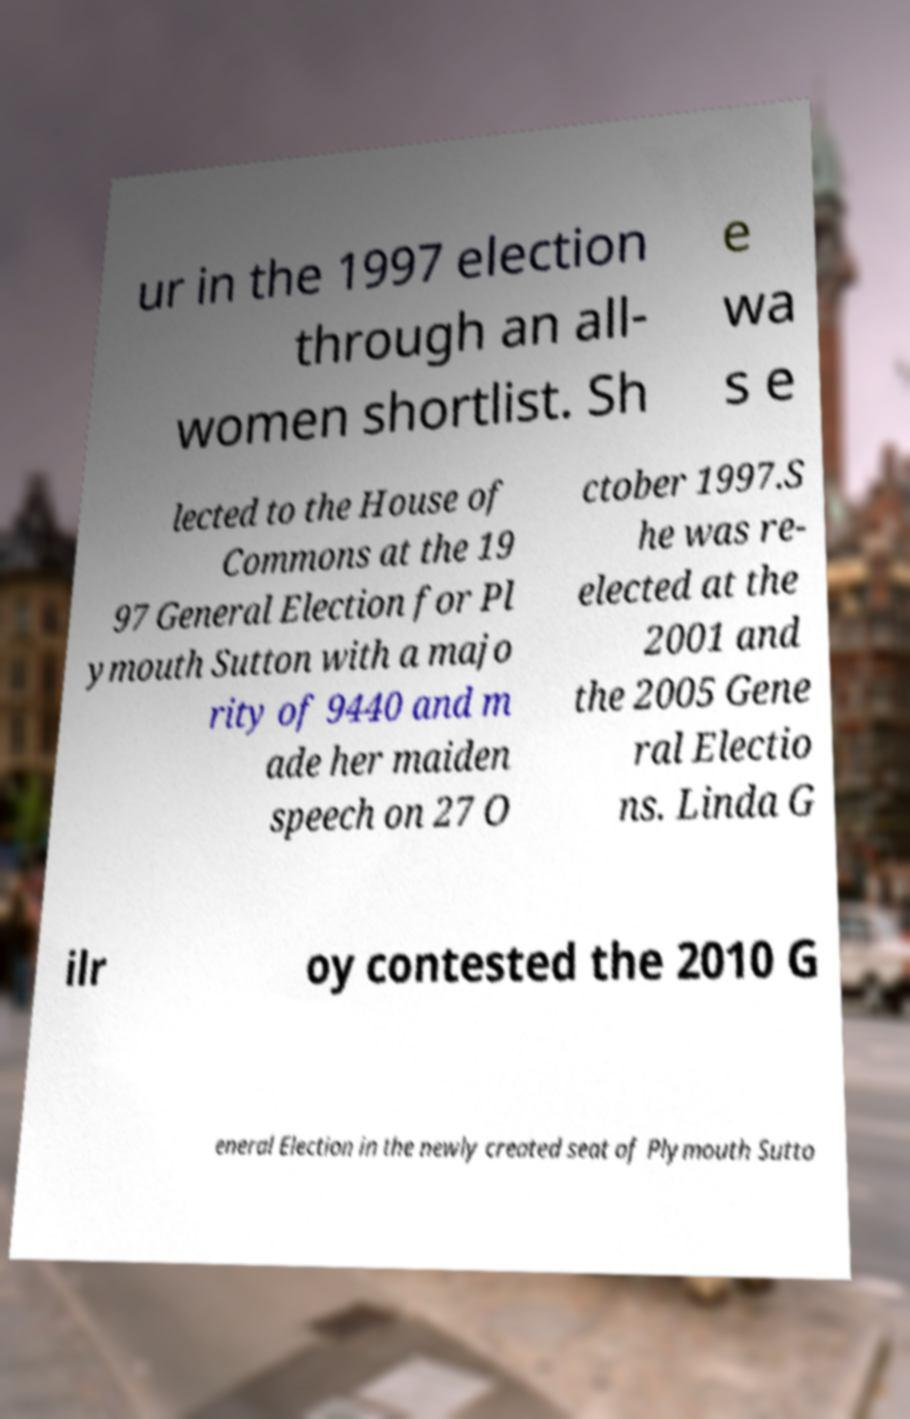I need the written content from this picture converted into text. Can you do that? ur in the 1997 election through an all- women shortlist. Sh e wa s e lected to the House of Commons at the 19 97 General Election for Pl ymouth Sutton with a majo rity of 9440 and m ade her maiden speech on 27 O ctober 1997.S he was re- elected at the 2001 and the 2005 Gene ral Electio ns. Linda G ilr oy contested the 2010 G eneral Election in the newly created seat of Plymouth Sutto 